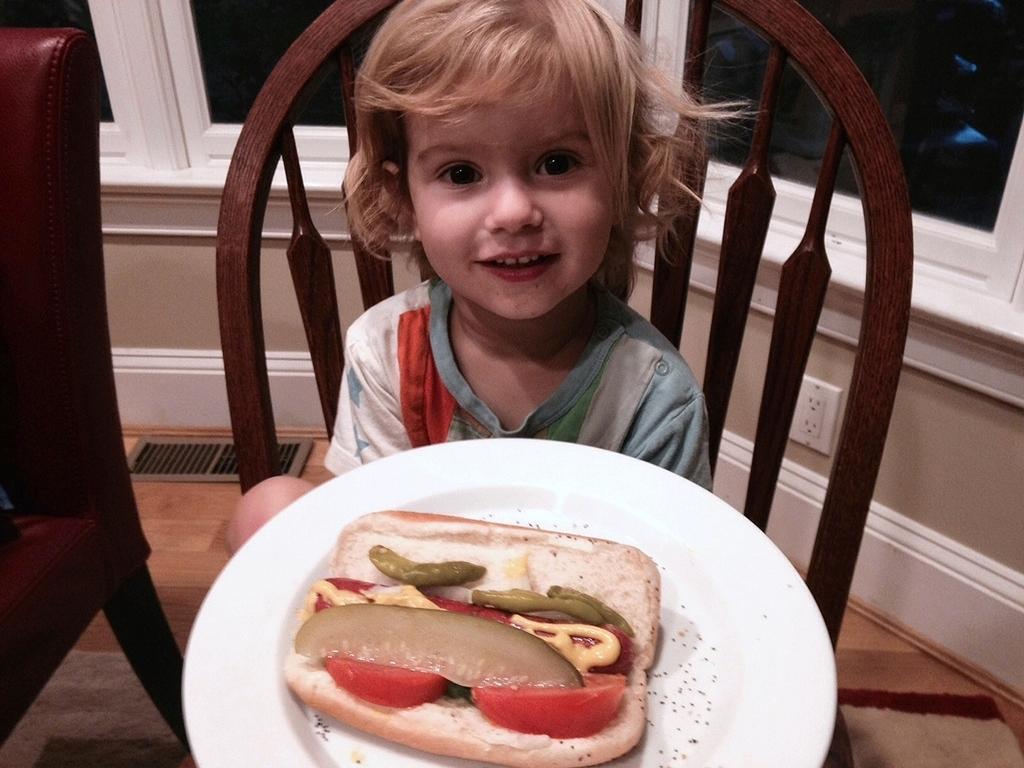Can you describe this image briefly? In this we can see food in the plate, and a kid is holding the plate, and he is seated on the chair. 